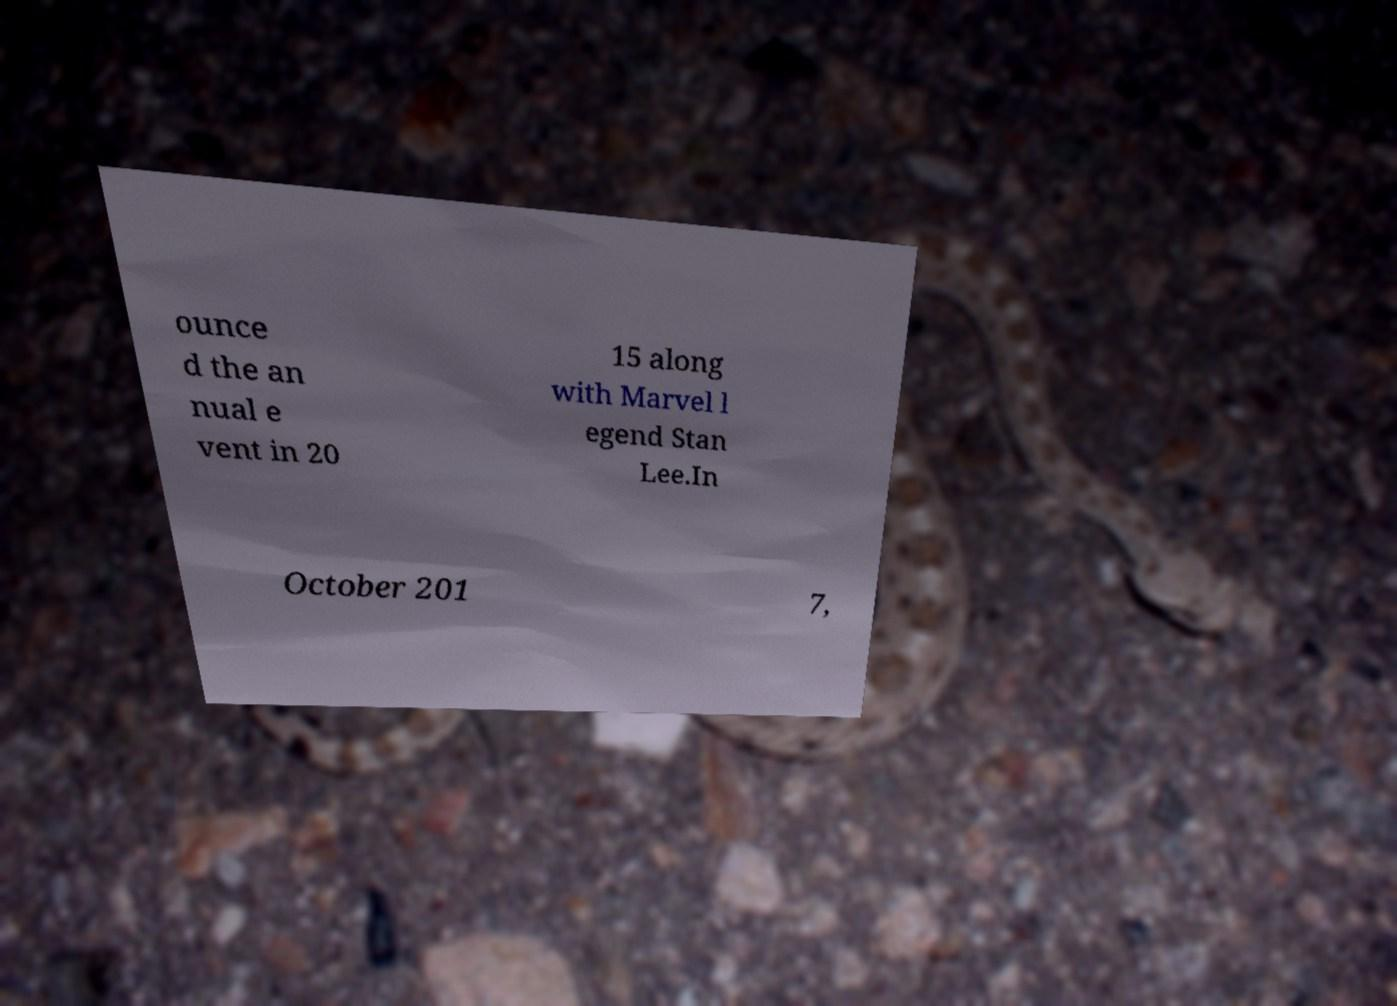I need the written content from this picture converted into text. Can you do that? ounce d the an nual e vent in 20 15 along with Marvel l egend Stan Lee.In October 201 7, 